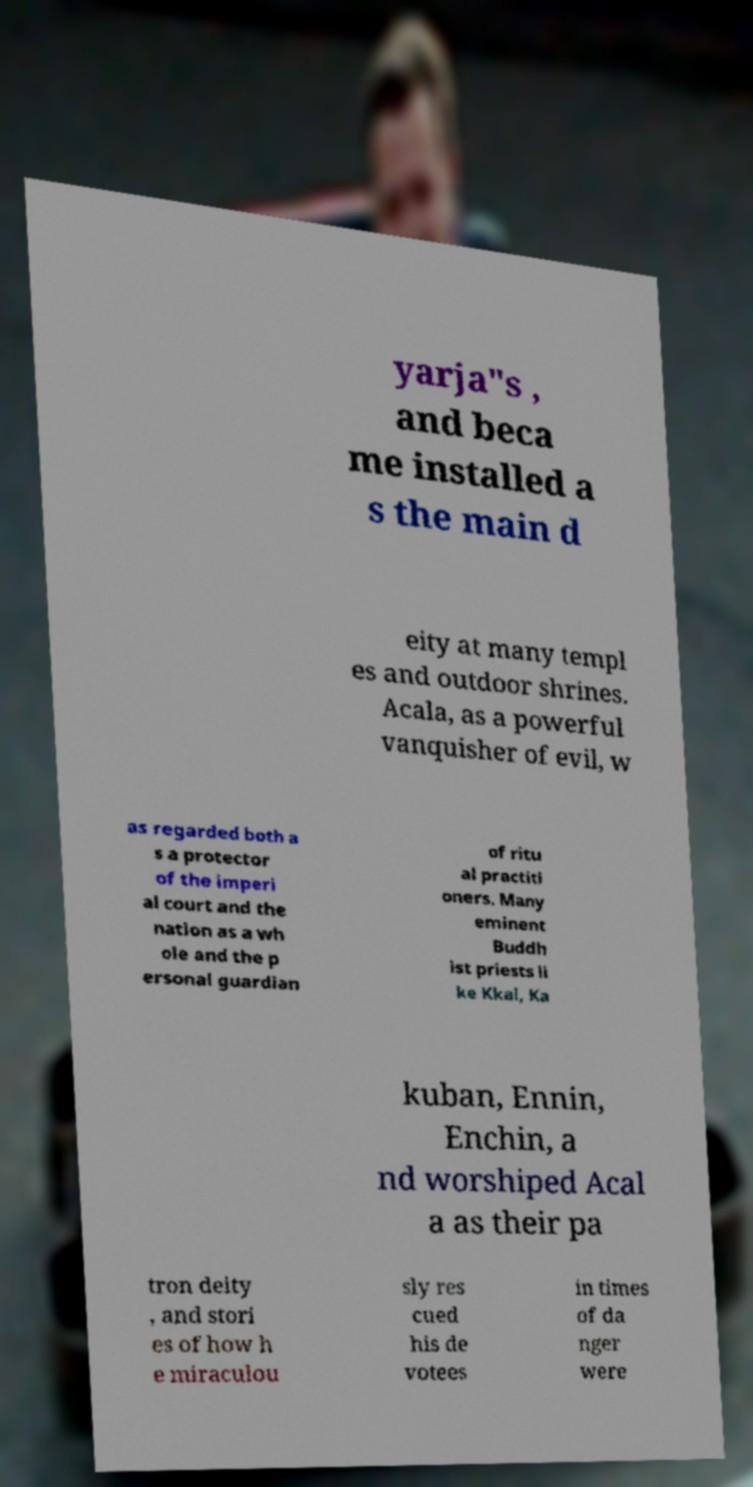Could you extract and type out the text from this image? yarja"s , and beca me installed a s the main d eity at many templ es and outdoor shrines. Acala, as a powerful vanquisher of evil, w as regarded both a s a protector of the imperi al court and the nation as a wh ole and the p ersonal guardian of ritu al practiti oners. Many eminent Buddh ist priests li ke Kkai, Ka kuban, Ennin, Enchin, a nd worshiped Acal a as their pa tron deity , and stori es of how h e miraculou sly res cued his de votees in times of da nger were 